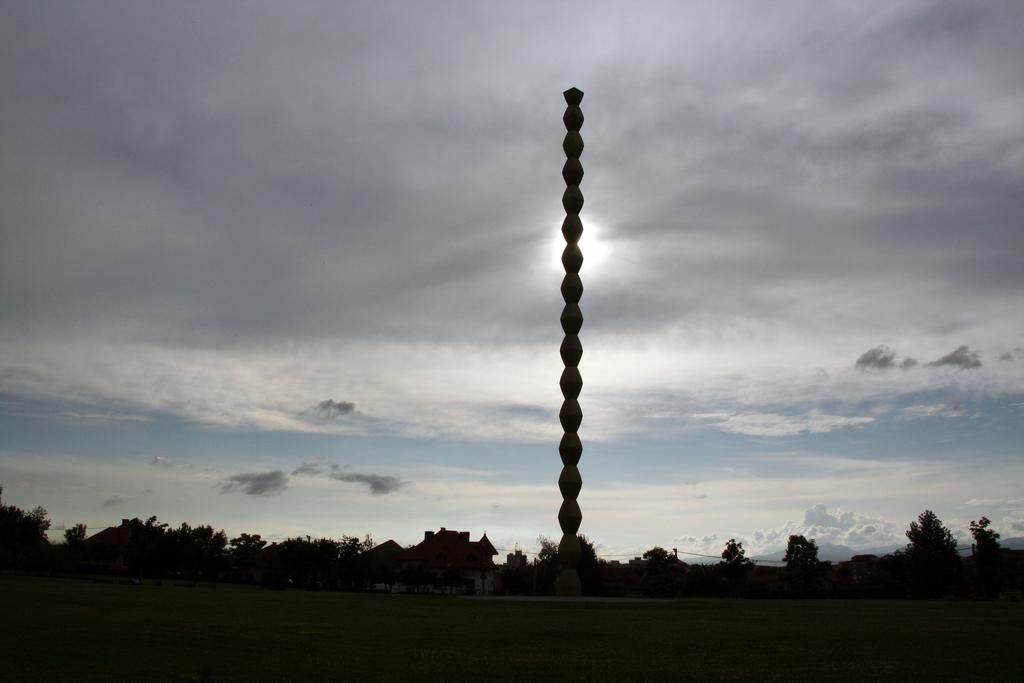What is the main feature of the image in the foreground? There is an open ground in the front of the image. What can be seen in the background of the image? There are trees, a house, clouds, and the sky visible in the background of the image. Can you describe the object in the center of the image? There is a pole in the center of the image. What type of riddle is being solved by the person standing next to the pole in the image? There is no person standing next to the pole in the image, and no riddle is being solved. What time of day is it in the image, considering the presence of the afternoon sun? There is no mention of the sun or the time of day in the image, so it cannot be determined from the image alone. 